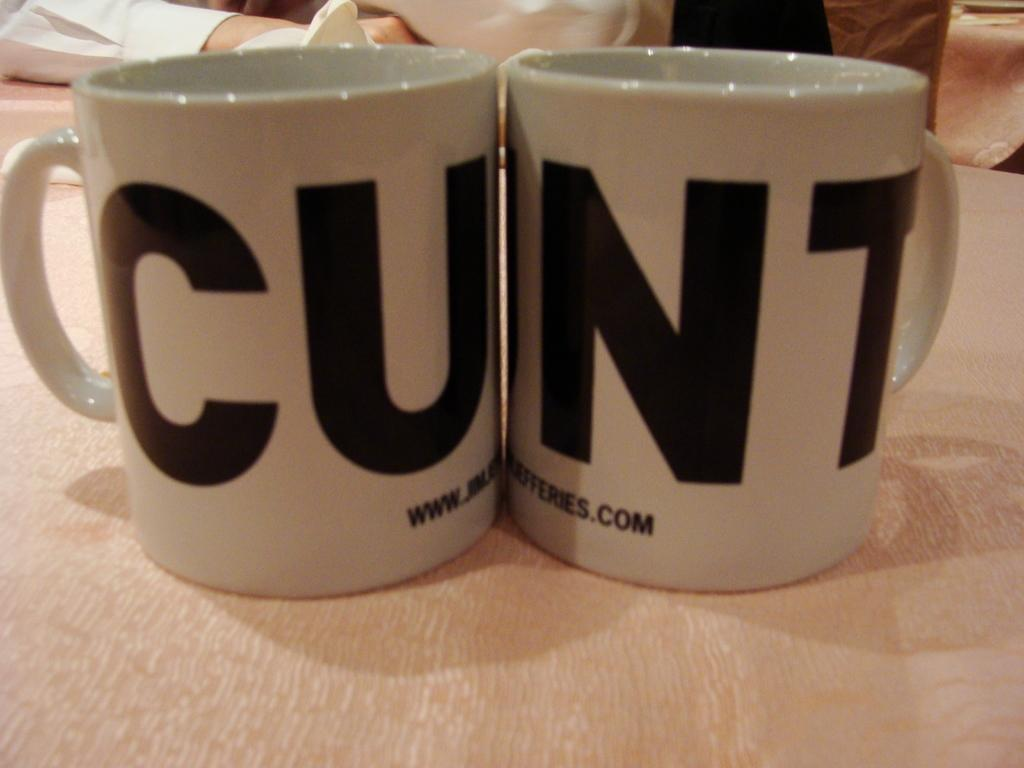Provide a one-sentence caption for the provided image. two cups sitting directly next to one another with a word written across them that reads "cunt". 